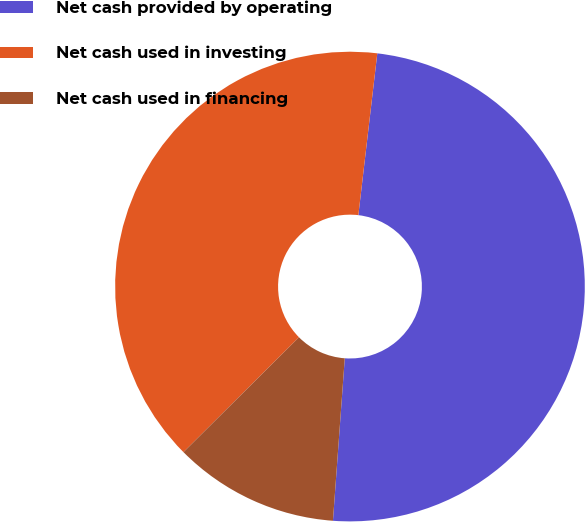<chart> <loc_0><loc_0><loc_500><loc_500><pie_chart><fcel>Net cash provided by operating<fcel>Net cash used in investing<fcel>Net cash used in financing<nl><fcel>49.3%<fcel>39.31%<fcel>11.39%<nl></chart> 